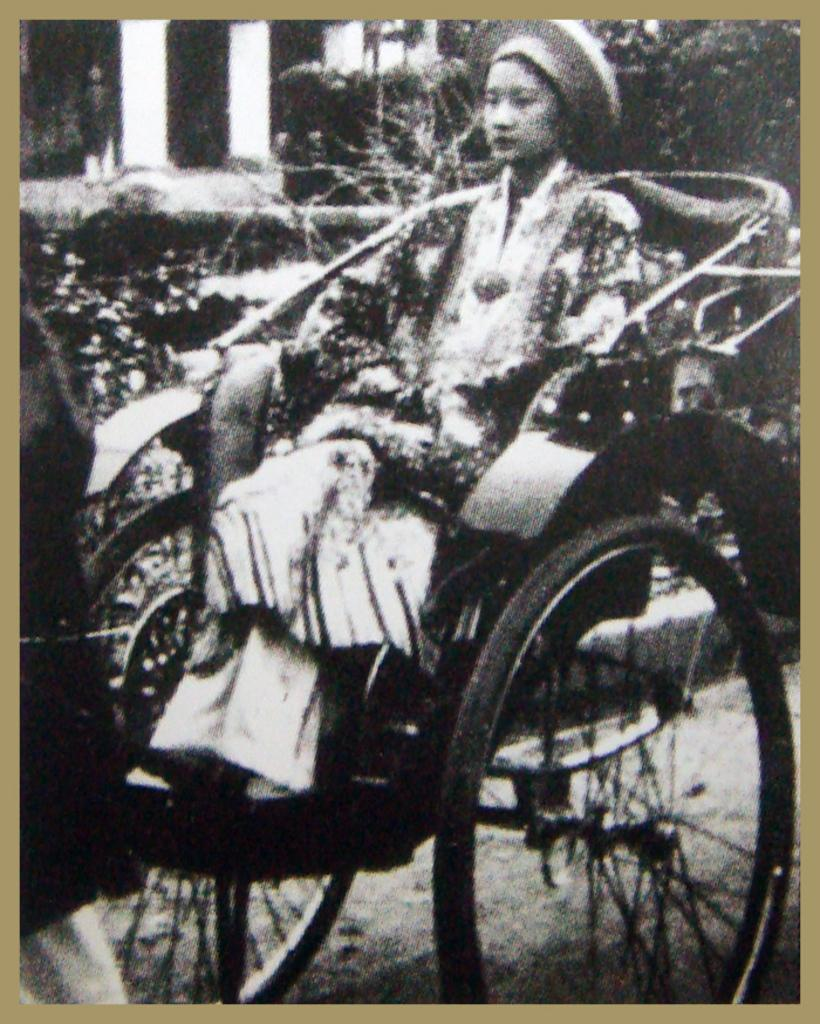What is the main subject of the image? There is a person sitting on a rickshaw in the image. What can be seen in the background of the image? There are trees visible in the image, and there is a person standing near a pillar. What type of plants are being used to make the stew in the image? There is no stew present in the image, and therefore no plants being used to make it. 